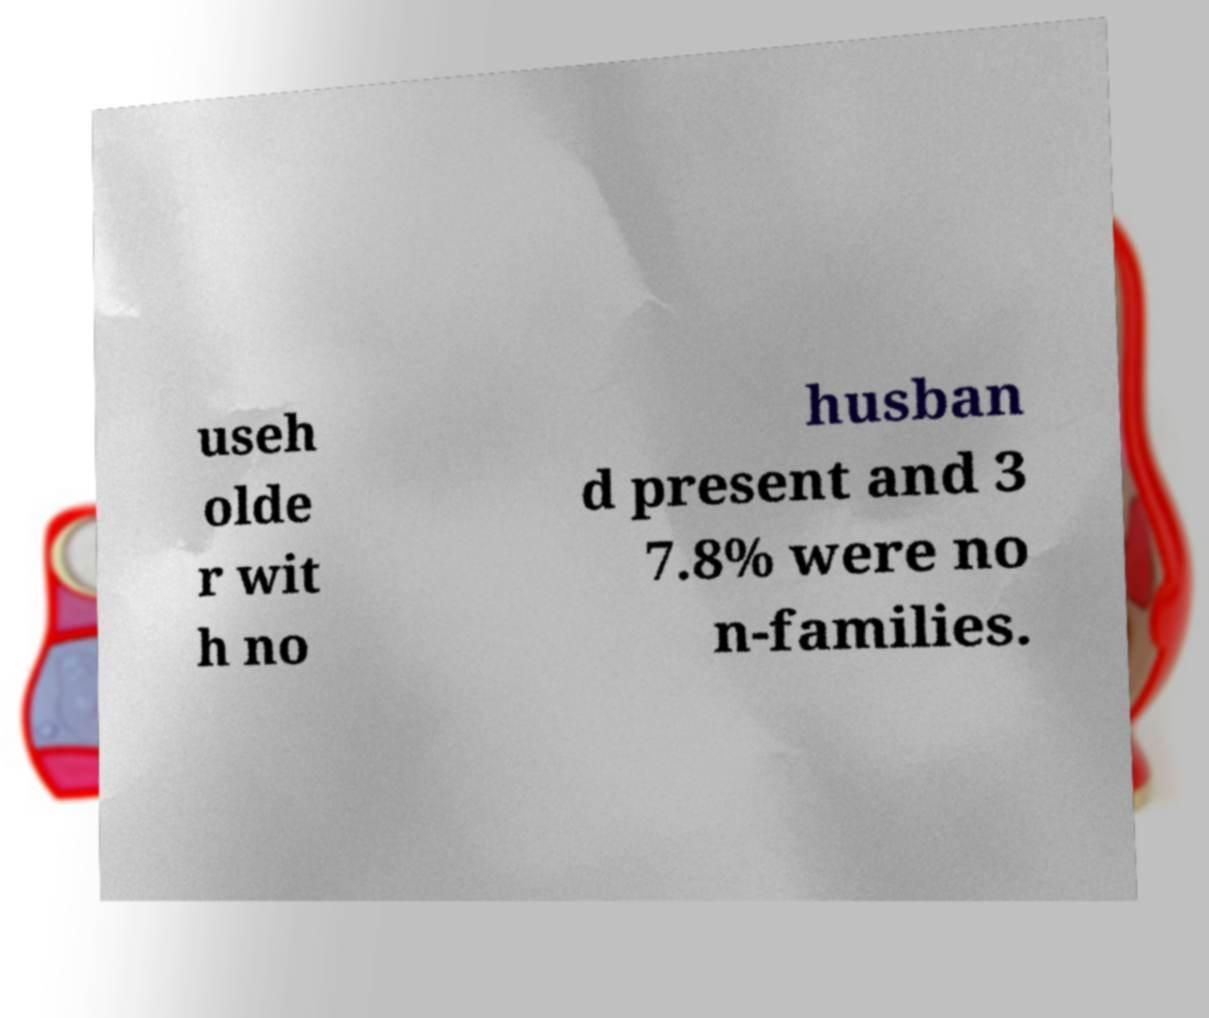For documentation purposes, I need the text within this image transcribed. Could you provide that? useh olde r wit h no husban d present and 3 7.8% were no n-families. 